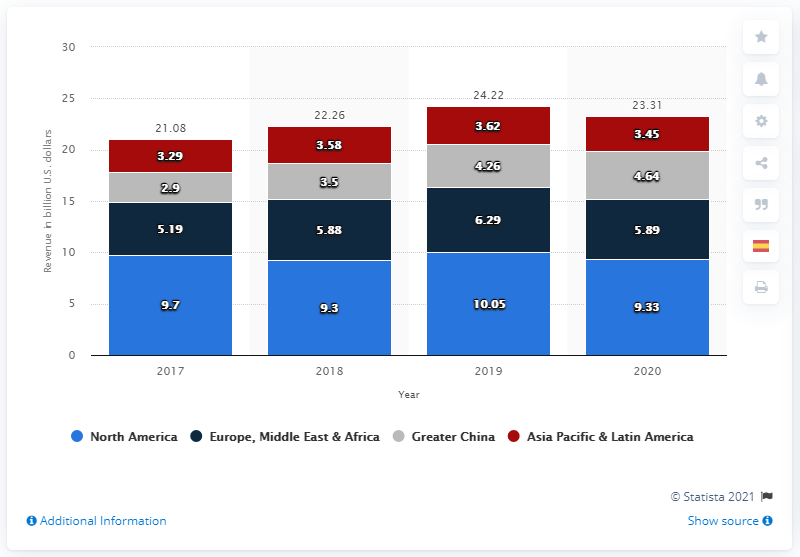Highlight a few significant elements in this photo. Nike's footwear net revenue from the North American market in dollars in 2020 was approximately $9.3 million. 